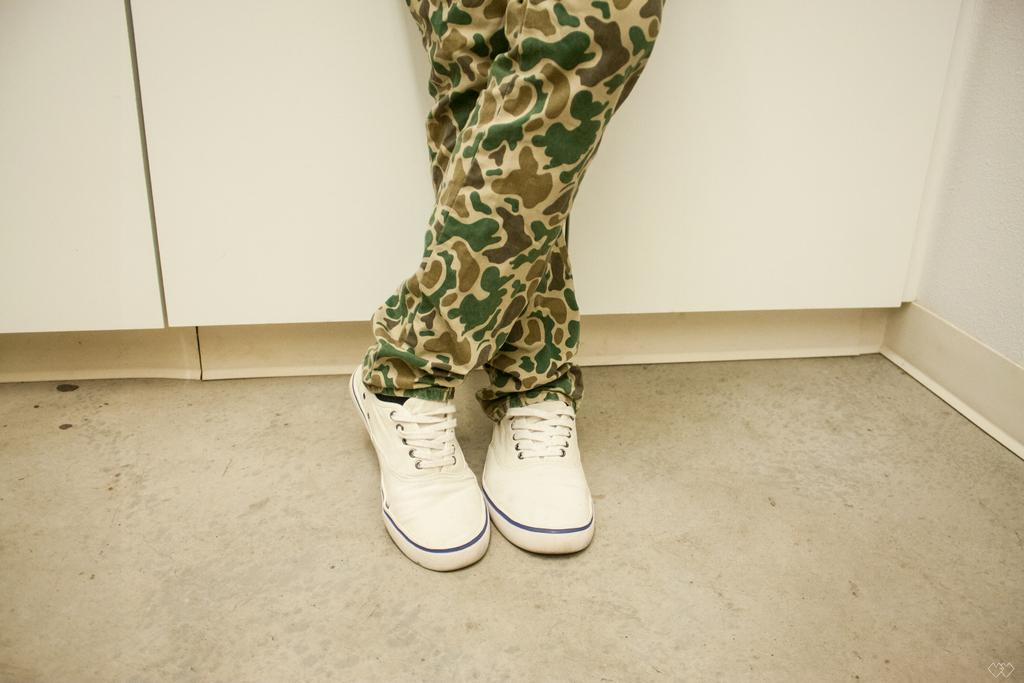What part of a person's body can be seen in the image? There are legs visible in the image. Where are the legs located? The legs are on the floor. What type of footwear is the person wearing? The person is wearing white-colored shoes. What type of gate can be seen in the image? There is no gate present in the image; it only shows a person's legs on the floor. 